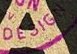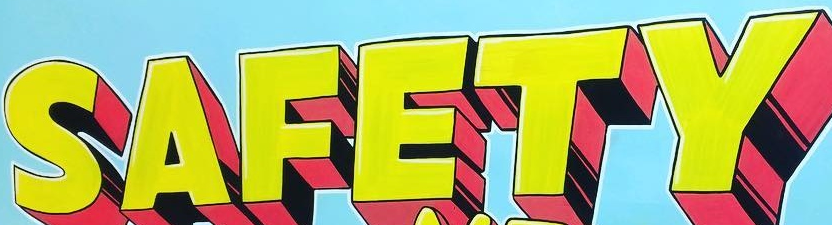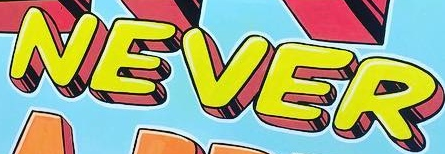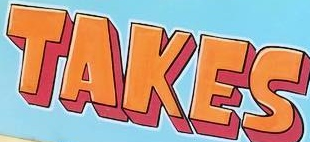What text is displayed in these images sequentially, separated by a semicolon? DESIGN; SAFETY; NEVER; TAKES 